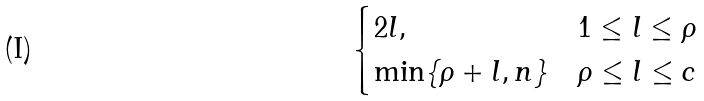Convert formula to latex. <formula><loc_0><loc_0><loc_500><loc_500>\begin{cases} 2 l , & 1 \leq l \leq \rho \\ \min \{ \rho + l , n \} & \rho \leq l \leq c \end{cases}</formula> 